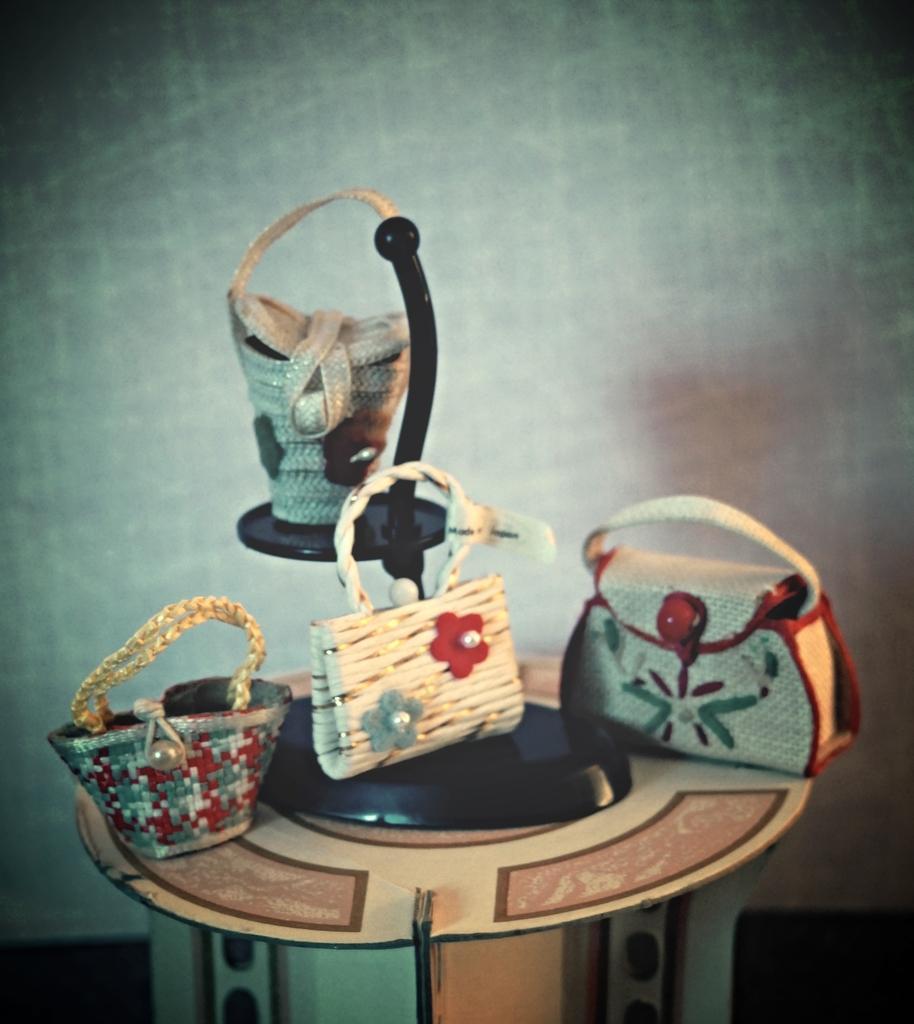How would you summarize this image in a sentence or two? Four hand bags made of miniature art are shown in the picture. 